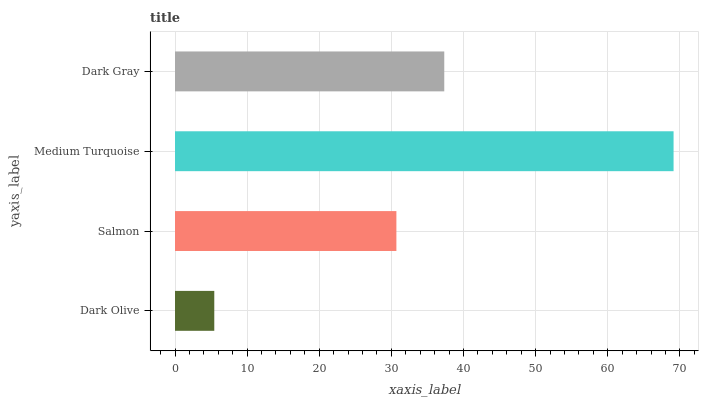Is Dark Olive the minimum?
Answer yes or no. Yes. Is Medium Turquoise the maximum?
Answer yes or no. Yes. Is Salmon the minimum?
Answer yes or no. No. Is Salmon the maximum?
Answer yes or no. No. Is Salmon greater than Dark Olive?
Answer yes or no. Yes. Is Dark Olive less than Salmon?
Answer yes or no. Yes. Is Dark Olive greater than Salmon?
Answer yes or no. No. Is Salmon less than Dark Olive?
Answer yes or no. No. Is Dark Gray the high median?
Answer yes or no. Yes. Is Salmon the low median?
Answer yes or no. Yes. Is Medium Turquoise the high median?
Answer yes or no. No. Is Dark Olive the low median?
Answer yes or no. No. 